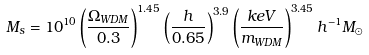<formula> <loc_0><loc_0><loc_500><loc_500>M _ { s } = 1 0 ^ { 1 0 } \left ( \frac { \Omega _ { W D M } } { 0 . 3 } \right ) ^ { 1 . 4 5 } \left ( \frac { h } { 0 . 6 5 } \right ) ^ { 3 . 9 } \left ( \frac { k e V } { m _ { W D M } } \right ) ^ { 3 . 4 5 } h ^ { - 1 } M _ { \odot }</formula> 